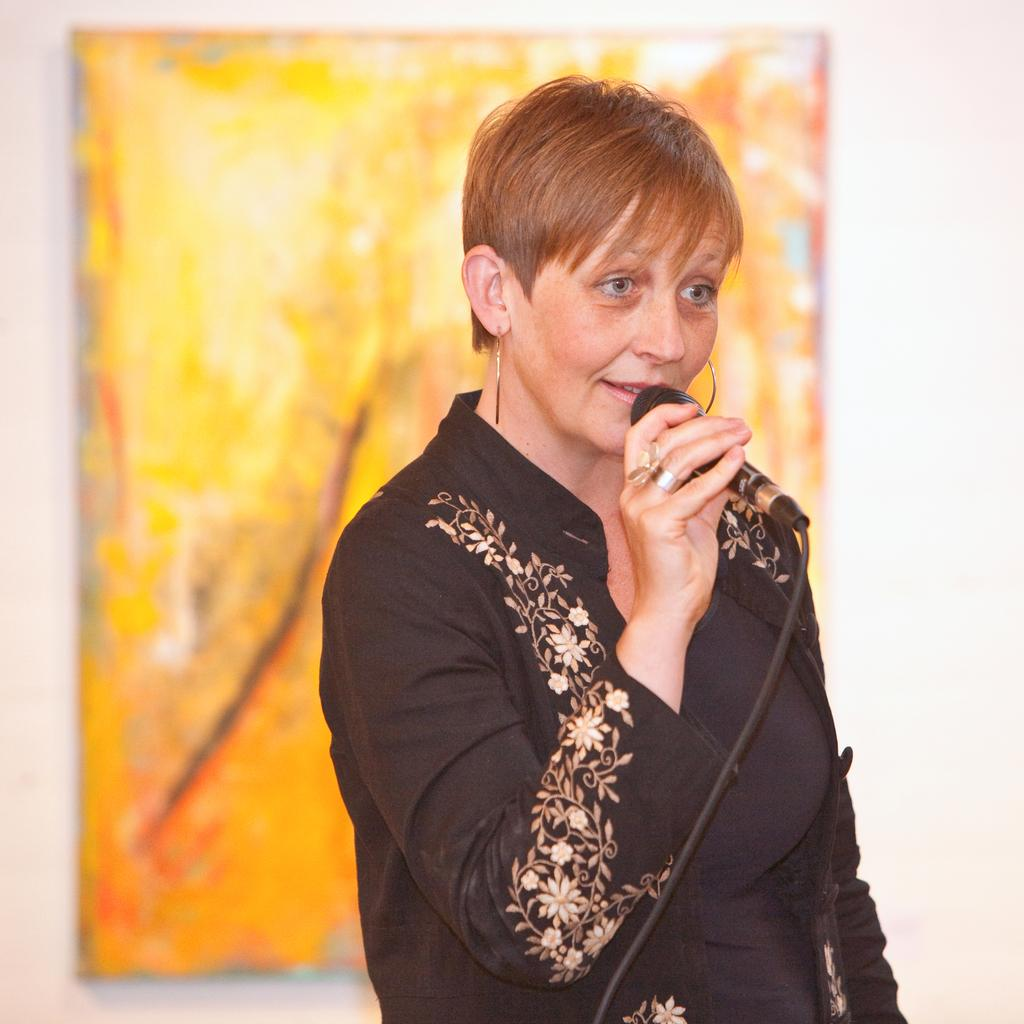Who is present in the image? There is a woman in the image. What is the woman holding in her hand? The woman is holding a mic with her hand. What can be seen in the background of the image? There is a frame on the wall in the background of the image. How does the woman use the zephyr to enhance her performance in the image? There is no mention of a zephyr in the image, so it cannot be used to enhance her performance. 